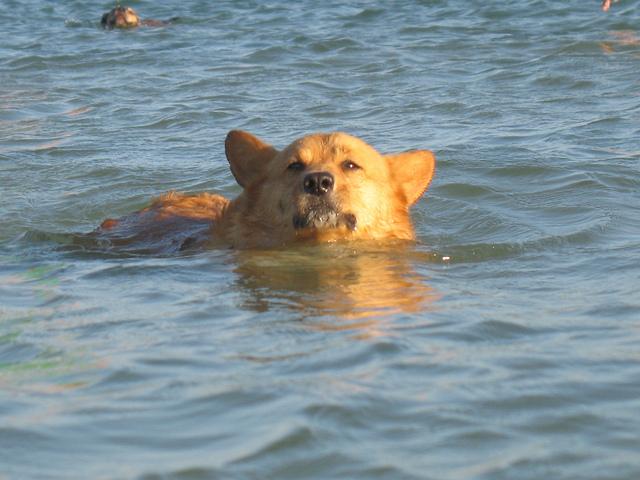Does this animal have fur?
Write a very short answer. Yes. Is the dog in a swimming pool?
Concise answer only. No. Can you see more than 2 bears?
Give a very brief answer. No. Is this a baby seal?
Be succinct. No. What material is the dog playing in?
Concise answer only. Water. 